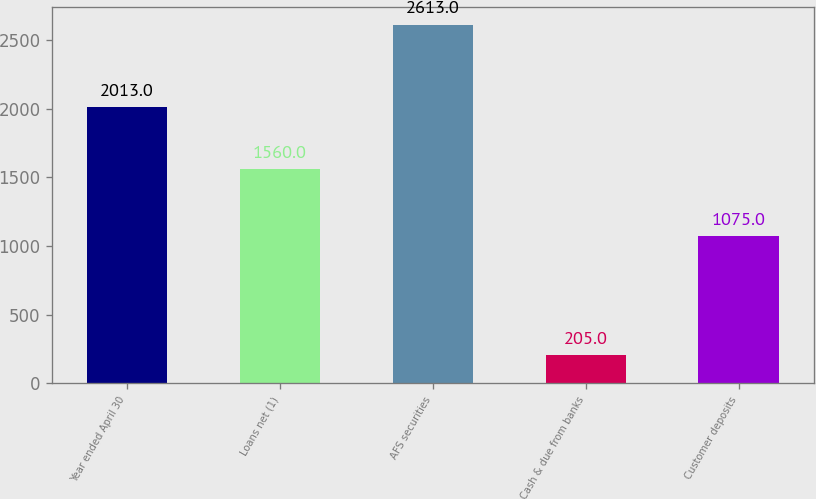<chart> <loc_0><loc_0><loc_500><loc_500><bar_chart><fcel>Year ended April 30<fcel>Loans net (1)<fcel>AFS securities<fcel>Cash & due from banks<fcel>Customer deposits<nl><fcel>2013<fcel>1560<fcel>2613<fcel>205<fcel>1075<nl></chart> 